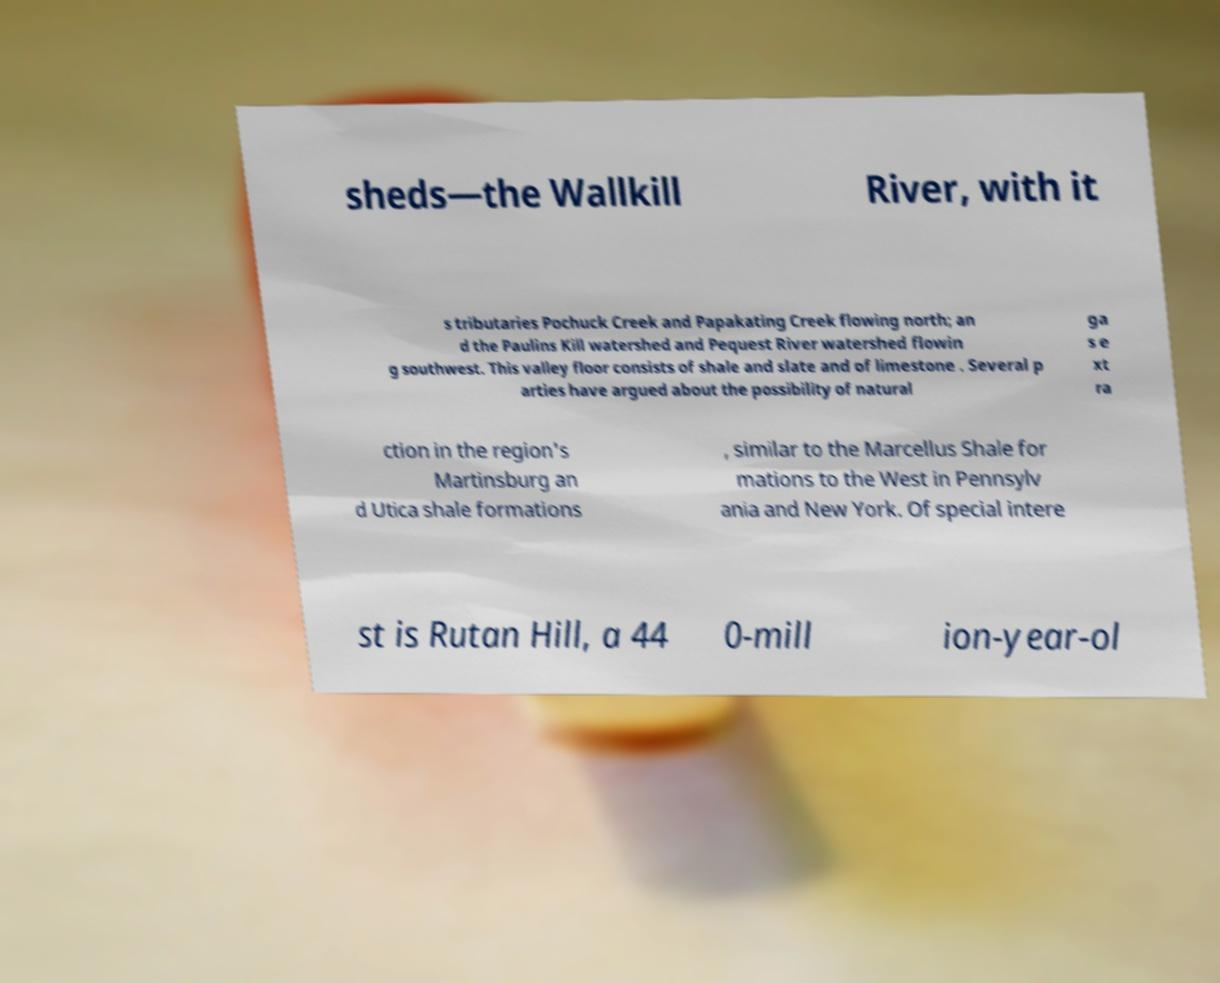Can you accurately transcribe the text from the provided image for me? sheds—the Wallkill River, with it s tributaries Pochuck Creek and Papakating Creek flowing north; an d the Paulins Kill watershed and Pequest River watershed flowin g southwest. This valley floor consists of shale and slate and of limestone . Several p arties have argued about the possibility of natural ga s e xt ra ction in the region's Martinsburg an d Utica shale formations , similar to the Marcellus Shale for mations to the West in Pennsylv ania and New York. Of special intere st is Rutan Hill, a 44 0-mill ion-year-ol 